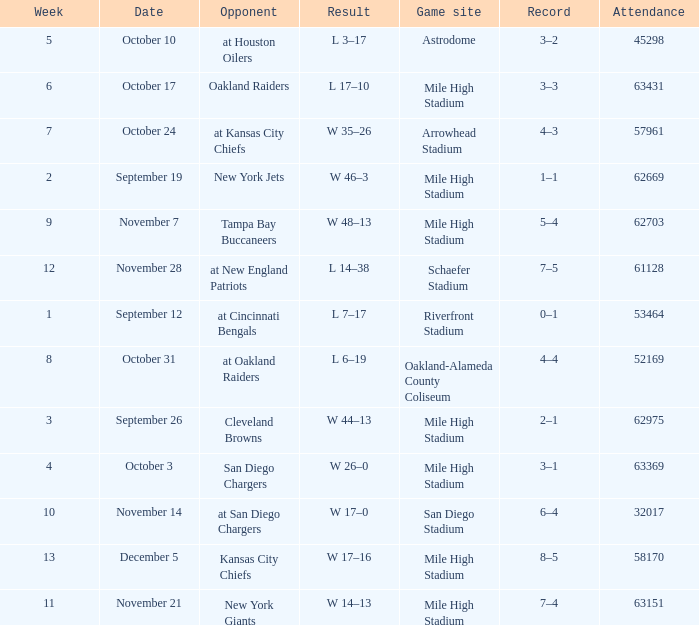What was the week number when the opponent was the New York Jets? 2.0. 